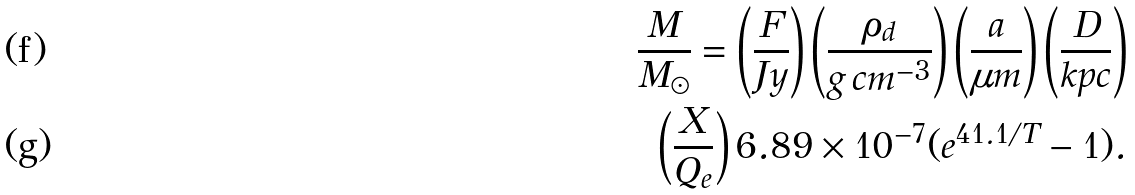<formula> <loc_0><loc_0><loc_500><loc_500>\frac { M } { M _ { \odot } } = \left ( { \frac { F } { J y } } \right ) \left ( { \frac { \rho _ { d } } { g \, c m ^ { - 3 } } } \right ) \left ( { \frac { a } { \mu m } } \right ) \left ( { \frac { D } { k p c } } \right ) \\ \left ( { \frac { X } { Q _ { e } } } \right ) 6 . 8 9 \times 1 0 ^ { - 7 } ( e ^ { 4 1 . 1 / T } - 1 ) .</formula> 